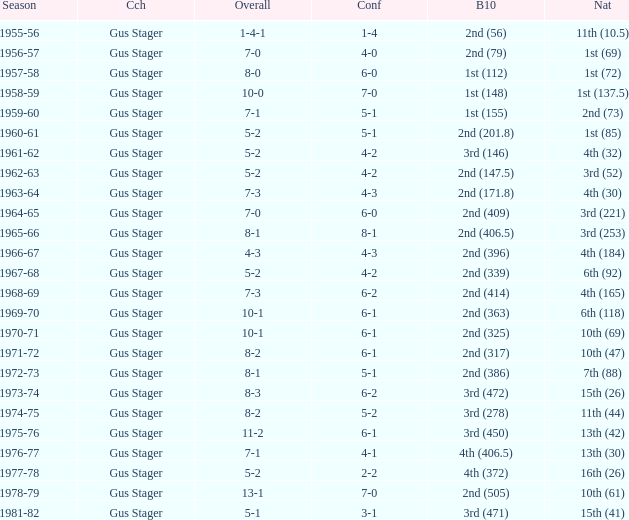What is the Coach with a Big Ten that is 1st (148)? Gus Stager. 